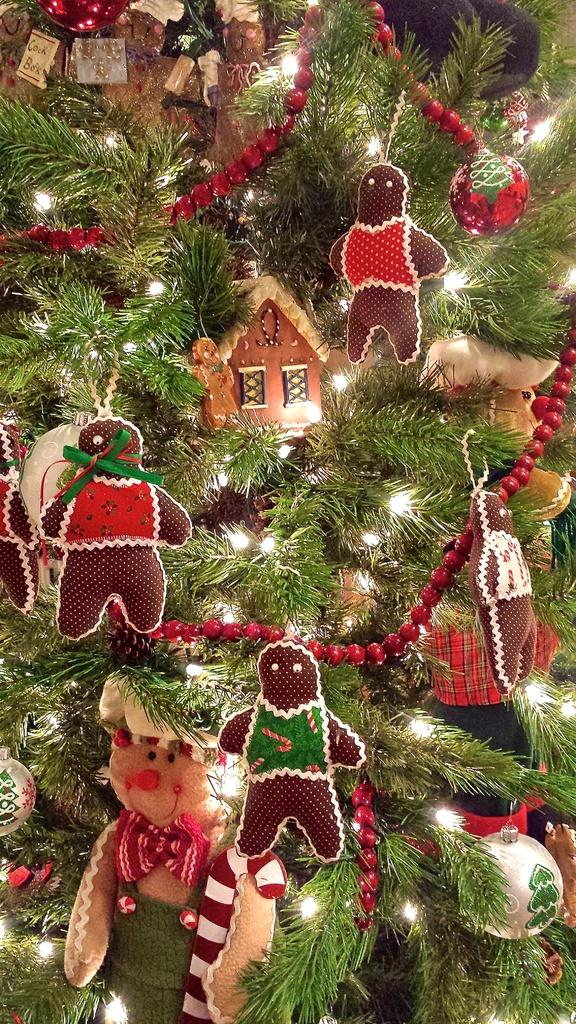What type of tree is in the image? There is a Christmas tree in the image. What decorations are on the Christmas tree? The Christmas tree has toys, lights, and balls on it. Can you describe a specific decoration on the tree? There is a toy house on the Christmas tree. What type of pump is visible near the Christmas tree? There is no pump present in the image; it features a Christmas tree with various decorations. 